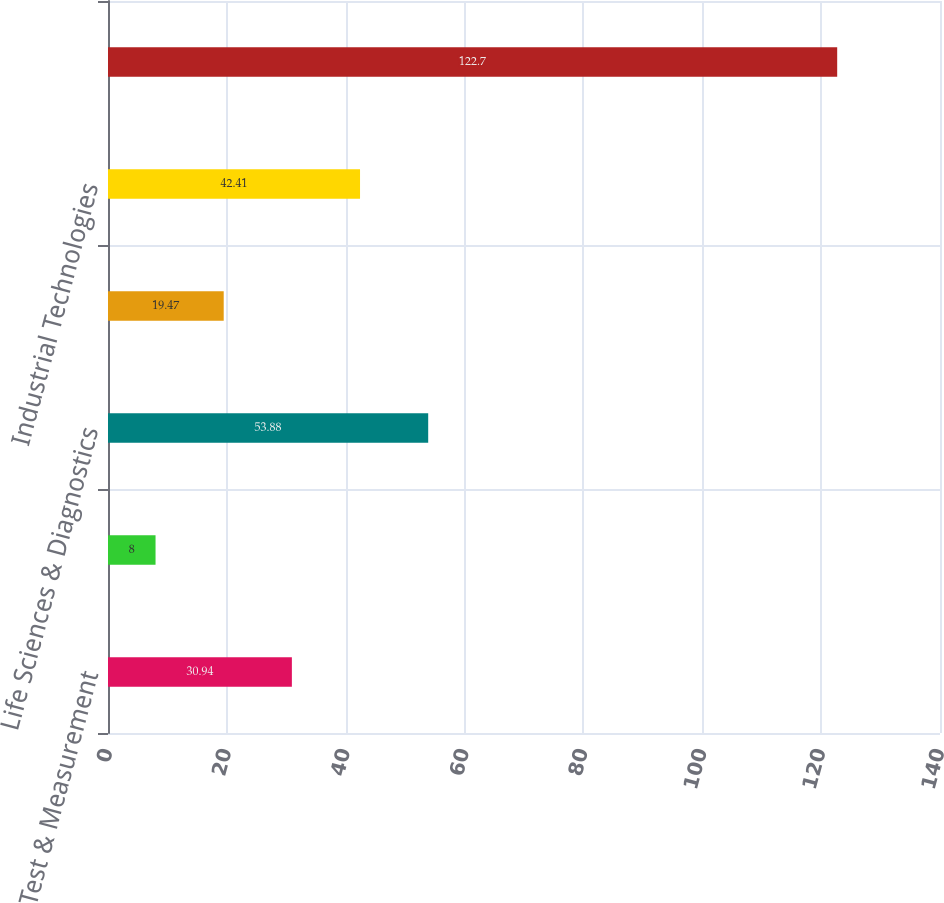<chart> <loc_0><loc_0><loc_500><loc_500><bar_chart><fcel>Test & Measurement<fcel>Environmental<fcel>Life Sciences & Diagnostics<fcel>Dental<fcel>Industrial Technologies<fcel>Total<nl><fcel>30.94<fcel>8<fcel>53.88<fcel>19.47<fcel>42.41<fcel>122.7<nl></chart> 